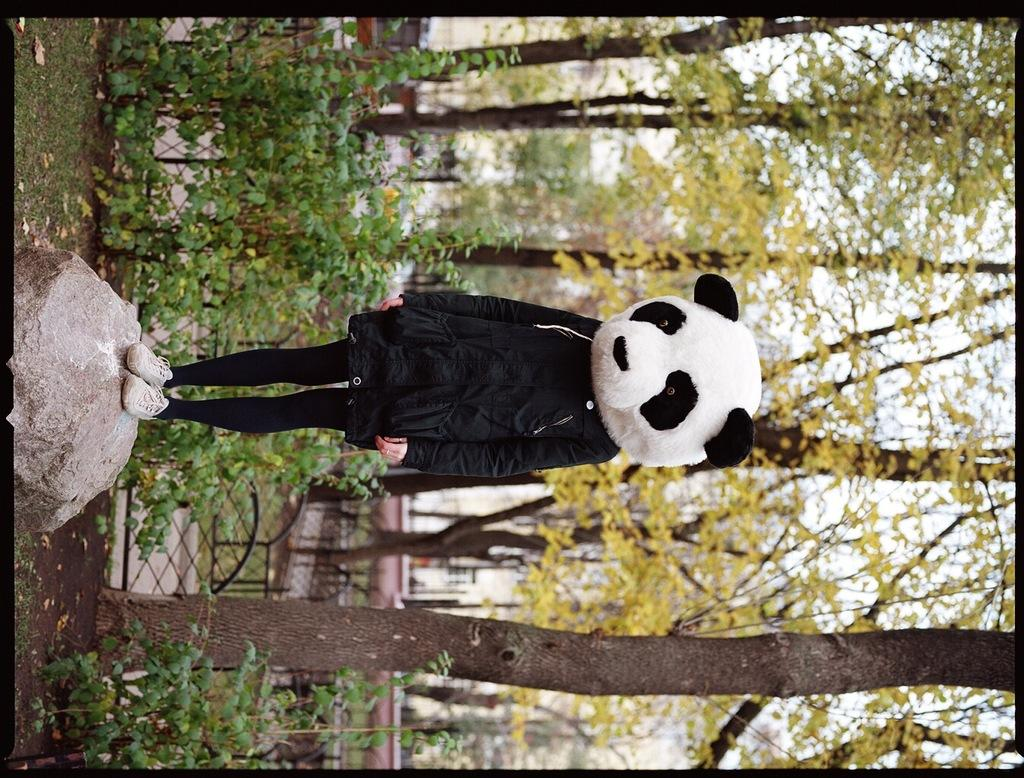What is the person in the image doing? The person is standing on a rock in the image. What is the person wearing on their face? The person is wearing a panda mask. What type of natural environment is visible in the image? There are trees in the image. What type of hospital equipment can be seen in the image? There is no hospital equipment present in the image. What type of lace is being used to decorate the trees in the image? There is no lace present in the image, and the trees are not being decorated. 